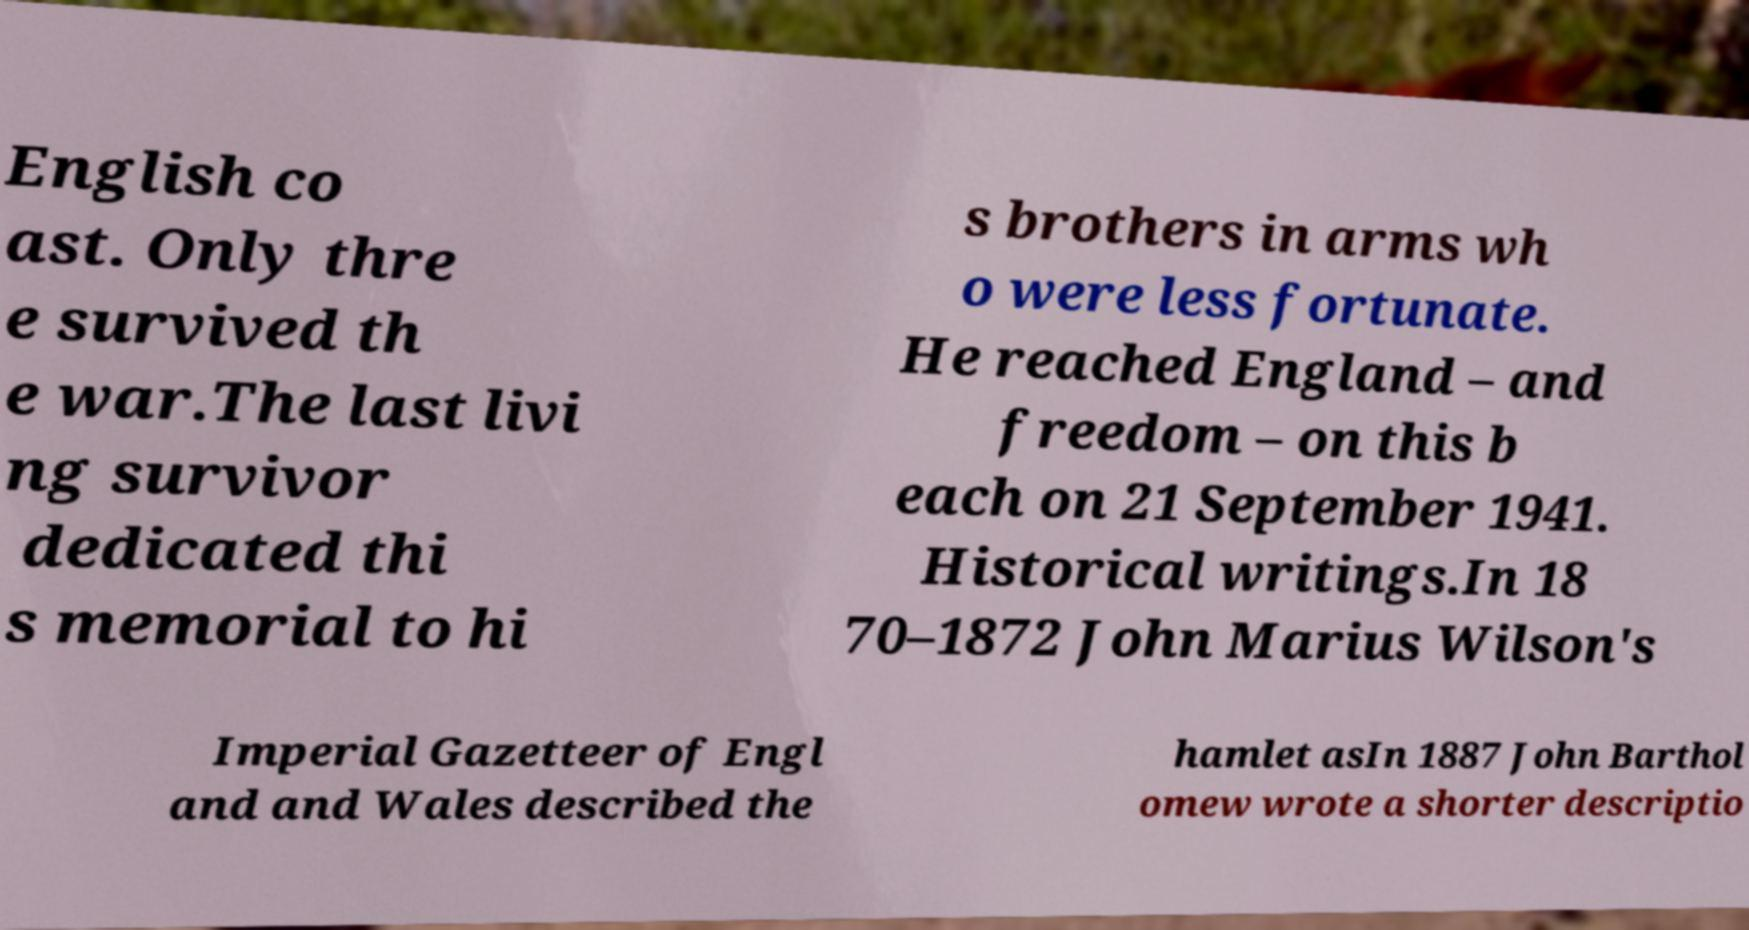Please read and relay the text visible in this image. What does it say? English co ast. Only thre e survived th e war.The last livi ng survivor dedicated thi s memorial to hi s brothers in arms wh o were less fortunate. He reached England – and freedom – on this b each on 21 September 1941. Historical writings.In 18 70–1872 John Marius Wilson's Imperial Gazetteer of Engl and and Wales described the hamlet asIn 1887 John Barthol omew wrote a shorter descriptio 